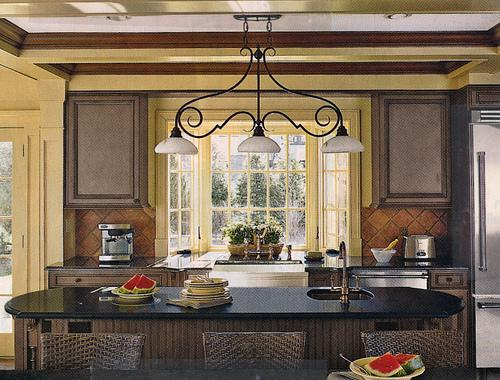In which one of these months do people like to eat this fruit? july 